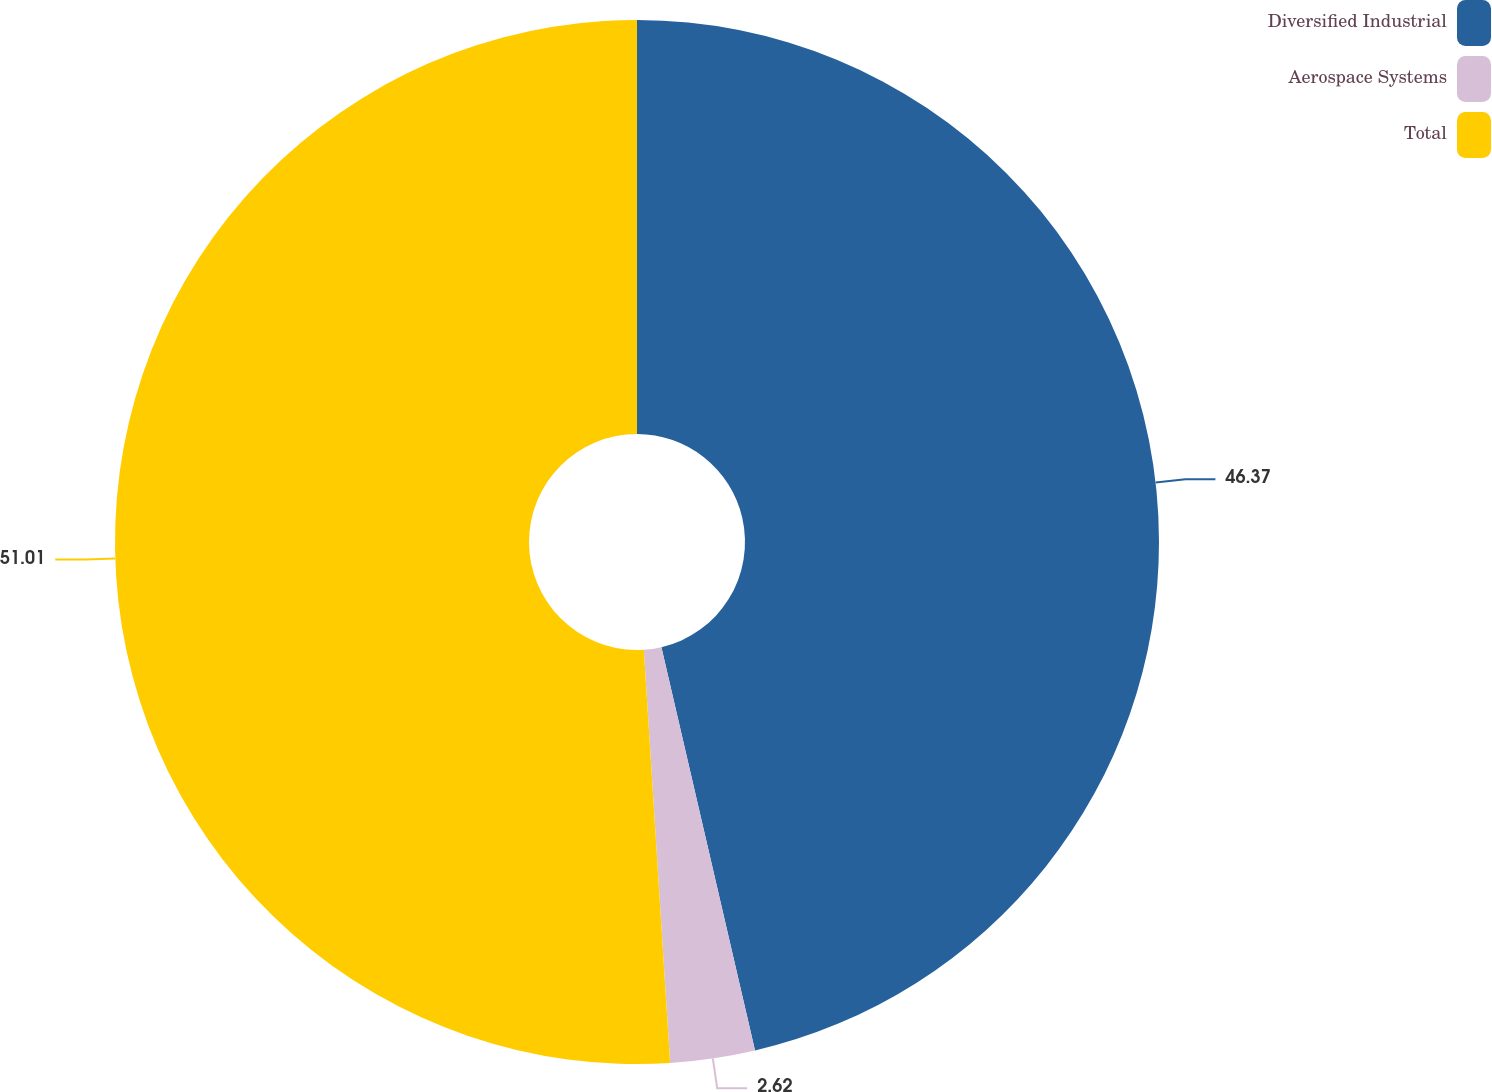Convert chart to OTSL. <chart><loc_0><loc_0><loc_500><loc_500><pie_chart><fcel>Diversified Industrial<fcel>Aerospace Systems<fcel>Total<nl><fcel>46.37%<fcel>2.62%<fcel>51.01%<nl></chart> 